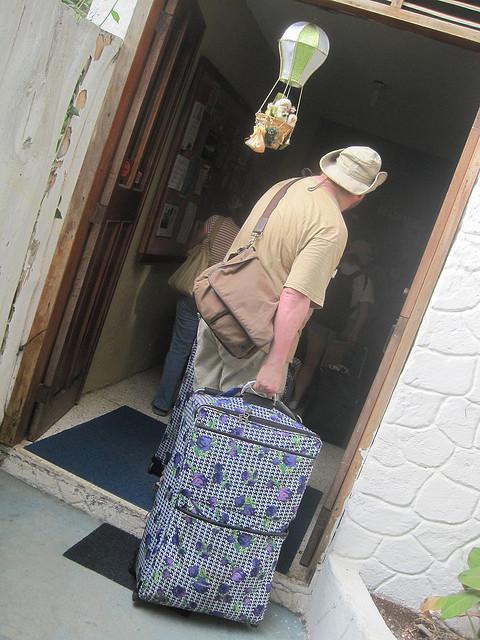What is hanging in the doorway?
Quick response, please. Balloon. What type of scene is this?
Concise answer only. Arriving. Is the man wearing a hat?
Short answer required. Yes. 